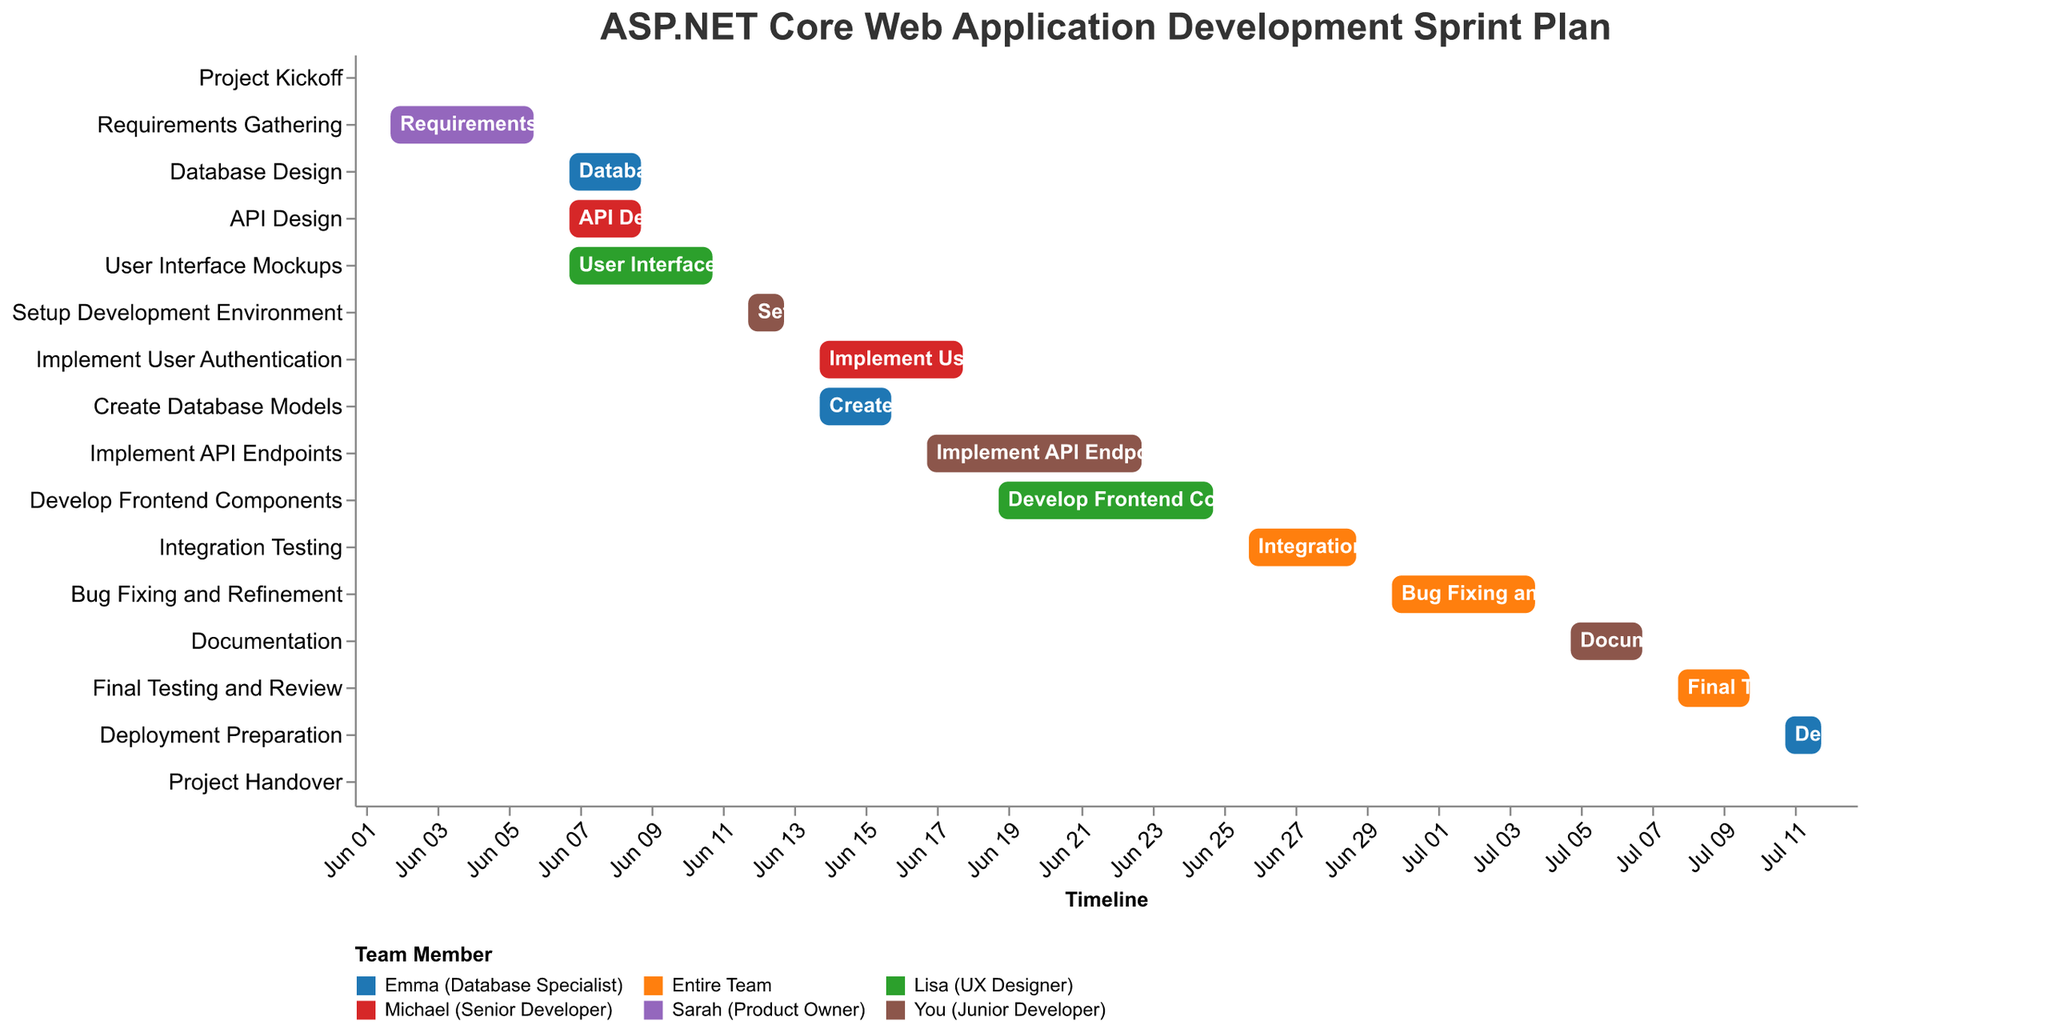What is the duration of the "Implement API Endpoints" task? Look at the task "Implement API Endpoints" and count the number of days from the start date (June 17) to the end date (June 23).
Answer: 7 days Which tasks are assigned to the entire team? Look for tasks in the chart where the assigned member is "Entire Team".
Answer: Project Kickoff, Integration Testing, Bug Fixing and Refinement, Final Testing and Review How many tasks involve Emma (Database Specialist)? Determine the number of tasks where "Emma (Database Specialist)" is listed as the assigned individual.
Answer: 4 When does the "Setup Development Environment" task start and end? Look at the task "Setup Development Environment" and note the start and end dates provided.
Answer: June 12 - June 13 Which task follows directly after "Bug Fixing and Refinement"? Identify the task that starts immediately after "Bug Fixing and Refinement" ends on July 4.
Answer: Documentation Compare the durations of "User Interface Mockups" and "Develop Frontend Components". Which one lasts longer? List the durations of both tasks and compare them. "User Interface Mockups" lasts 5 days, whereas "Develop Frontend Components" lasts 7 days.
Answer: Develop Frontend Components Which tasks overlap with "Create Database Models"? Look at the time frame of "Create Database Models" (June 14 - June 16) and identify tasks with overlapping time frames.
Answer: Implement User Authentication, Implement API Endpoints What is the first and last task of the project timeline? Identify the starting and ending dates of the overall project. The first task is "Project Kickoff" on June 1, and the last task is "Project Handover" on July 13.
Answer: Project Kickoff, Project Handover What tasks are both assigned to "You (Junior Developer)" and overlap in time? Find tasks assigned to "You (Junior Developer)" and check their start and end dates for overlaps. The overlapping tasks are "Implement API Endpoints" (June 17 - June 23) and "Develop Frontend Components" (June 19 - June 25). Both overlap from June 19 to June 23.
Answer: Implement API Endpoints, Develop Frontend Components Which task has the shortest duration, and how long is it? List the tasks and their durations, then compare to find the shortest one. The task that lasts the shortest time is "Project Kickoff" with 1 day.
Answer: Project Kickoff, 1 day 